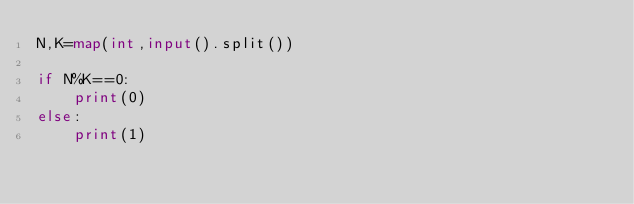<code> <loc_0><loc_0><loc_500><loc_500><_Python_>N,K=map(int,input().split())

if N%K==0:
    print(0)
else:
    print(1)
</code> 